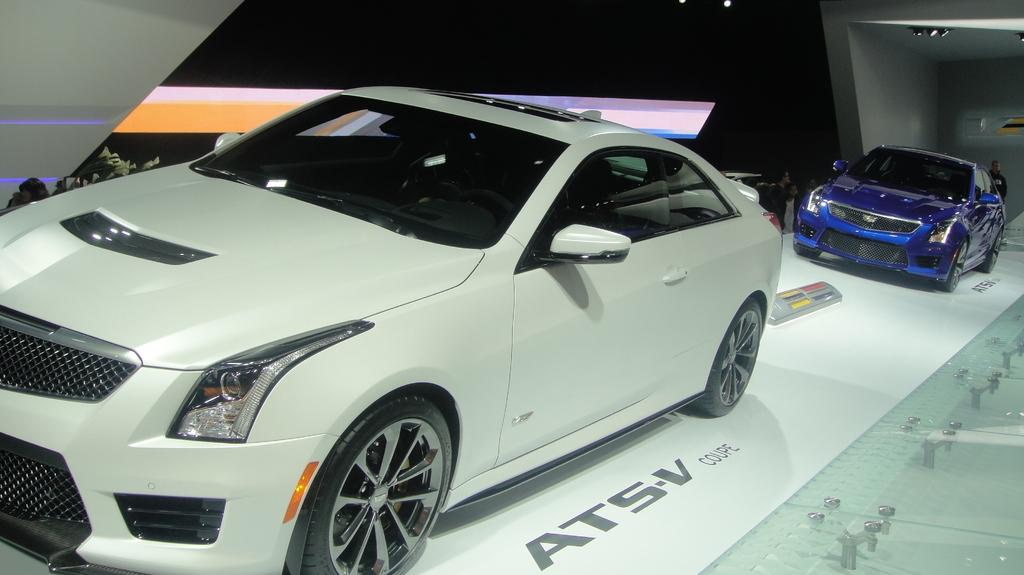Who or what is present in the image? There are people and vehicles in the image. What is the position of the vehicles in the image? The vehicles are on the floor in the image. Are there any additional features on the vehicles? Yes, there are lights on the roof of the vehicles. What can be seen beside the vehicles? There is a plant beside the vehicles in the image. What industry is being represented by the channel in the image? There is no channel or industry present in the image; it features people, vehicles, lights, and a plant. 